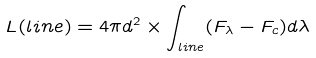Convert formula to latex. <formula><loc_0><loc_0><loc_500><loc_500>L ( l i n e ) = 4 \pi d ^ { 2 } \times \int _ { l i n e } ( F _ { \lambda } - F _ { c } ) d \lambda</formula> 